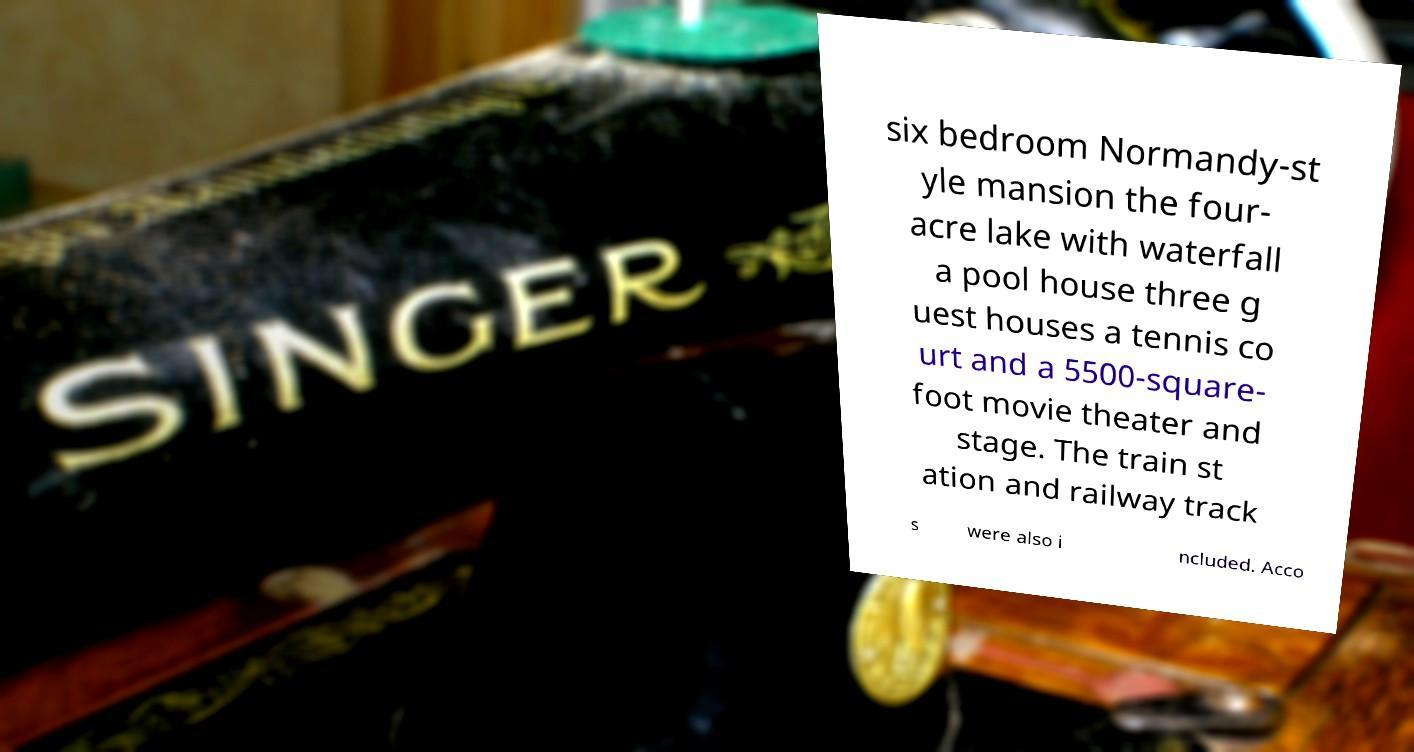I need the written content from this picture converted into text. Can you do that? six bedroom Normandy-st yle mansion the four- acre lake with waterfall a pool house three g uest houses a tennis co urt and a 5500-square- foot movie theater and stage. The train st ation and railway track s were also i ncluded. Acco 